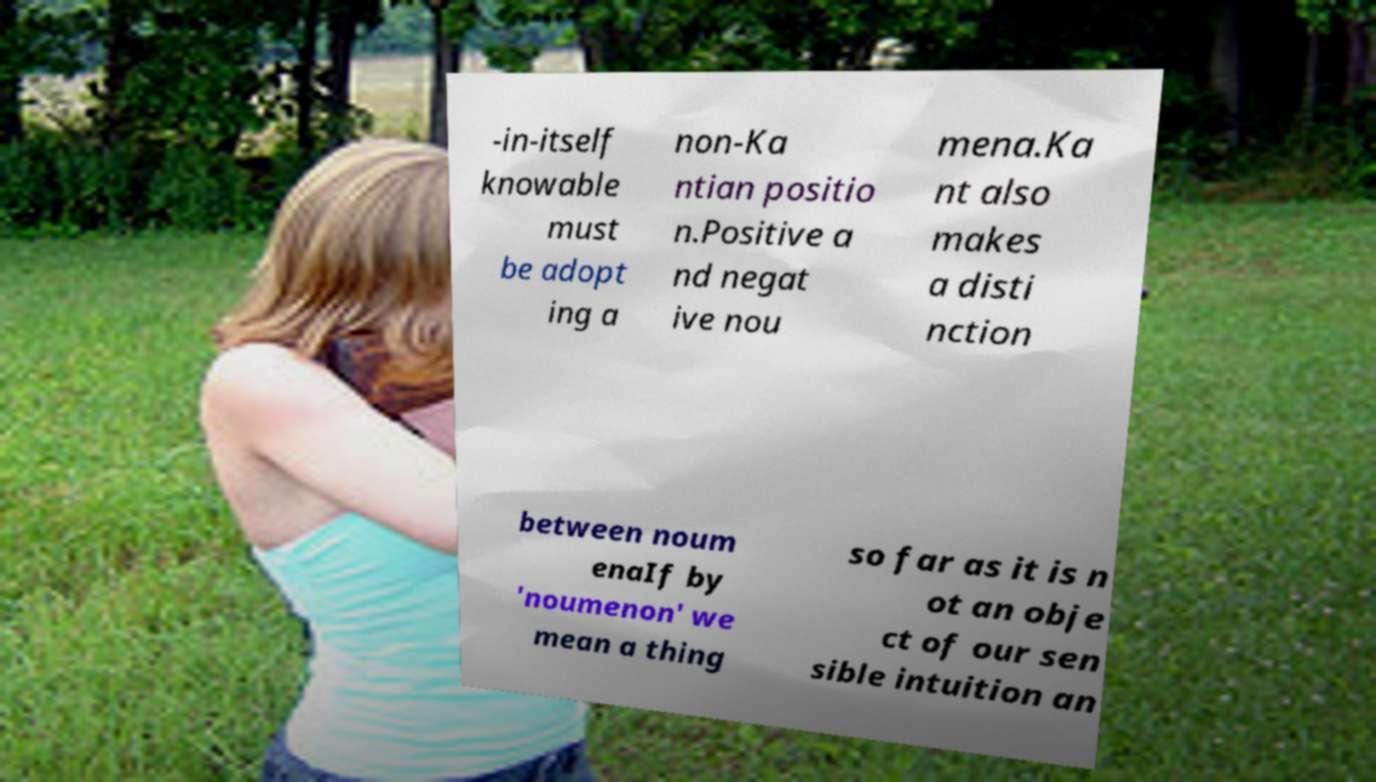I need the written content from this picture converted into text. Can you do that? -in-itself knowable must be adopt ing a non-Ka ntian positio n.Positive a nd negat ive nou mena.Ka nt also makes a disti nction between noum enaIf by 'noumenon' we mean a thing so far as it is n ot an obje ct of our sen sible intuition an 